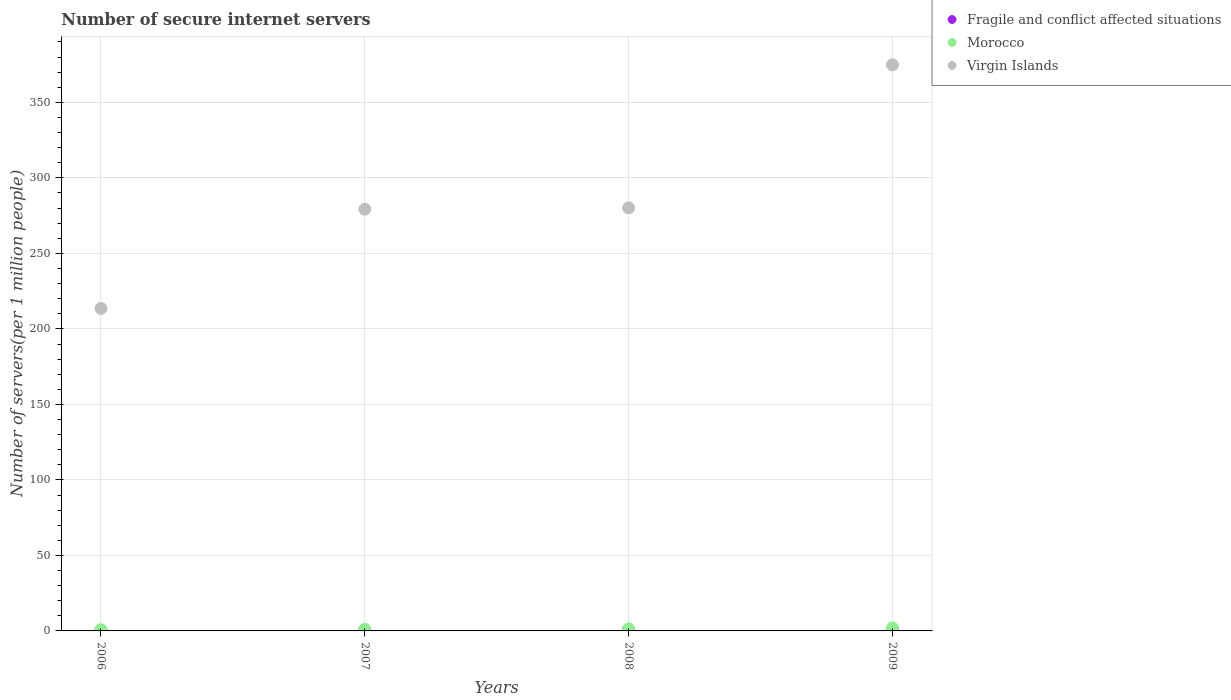How many different coloured dotlines are there?
Provide a short and direct response. 3. What is the number of secure internet servers in Virgin Islands in 2006?
Make the answer very short. 213.56. Across all years, what is the maximum number of secure internet servers in Fragile and conflict affected situations?
Make the answer very short. 0.55. Across all years, what is the minimum number of secure internet servers in Fragile and conflict affected situations?
Give a very brief answer. 0.33. In which year was the number of secure internet servers in Fragile and conflict affected situations maximum?
Make the answer very short. 2009. What is the total number of secure internet servers in Fragile and conflict affected situations in the graph?
Give a very brief answer. 1.84. What is the difference between the number of secure internet servers in Fragile and conflict affected situations in 2007 and that in 2009?
Give a very brief answer. -0.16. What is the difference between the number of secure internet servers in Virgin Islands in 2008 and the number of secure internet servers in Fragile and conflict affected situations in 2007?
Ensure brevity in your answer.  279.74. What is the average number of secure internet servers in Fragile and conflict affected situations per year?
Ensure brevity in your answer.  0.46. In the year 2009, what is the difference between the number of secure internet servers in Virgin Islands and number of secure internet servers in Morocco?
Give a very brief answer. 372.9. What is the ratio of the number of secure internet servers in Virgin Islands in 2006 to that in 2008?
Ensure brevity in your answer.  0.76. Is the number of secure internet servers in Fragile and conflict affected situations in 2007 less than that in 2008?
Offer a terse response. Yes. What is the difference between the highest and the second highest number of secure internet servers in Virgin Islands?
Your answer should be compact. 94.72. What is the difference between the highest and the lowest number of secure internet servers in Virgin Islands?
Provide a succinct answer. 161.3. What is the difference between two consecutive major ticks on the Y-axis?
Keep it short and to the point. 50. Does the graph contain any zero values?
Your response must be concise. No. Does the graph contain grids?
Offer a very short reply. Yes. How many legend labels are there?
Ensure brevity in your answer.  3. What is the title of the graph?
Ensure brevity in your answer.  Number of secure internet servers. Does "Marshall Islands" appear as one of the legend labels in the graph?
Provide a short and direct response. No. What is the label or title of the X-axis?
Your response must be concise. Years. What is the label or title of the Y-axis?
Offer a terse response. Number of servers(per 1 million people). What is the Number of servers(per 1 million people) of Fragile and conflict affected situations in 2006?
Your response must be concise. 0.33. What is the Number of servers(per 1 million people) of Morocco in 2006?
Your answer should be compact. 0.78. What is the Number of servers(per 1 million people) of Virgin Islands in 2006?
Provide a short and direct response. 213.56. What is the Number of servers(per 1 million people) in Fragile and conflict affected situations in 2007?
Provide a succinct answer. 0.4. What is the Number of servers(per 1 million people) of Morocco in 2007?
Ensure brevity in your answer.  1.06. What is the Number of servers(per 1 million people) of Virgin Islands in 2007?
Offer a very short reply. 279.27. What is the Number of servers(per 1 million people) of Fragile and conflict affected situations in 2008?
Offer a terse response. 0.55. What is the Number of servers(per 1 million people) of Morocco in 2008?
Give a very brief answer. 1.4. What is the Number of servers(per 1 million people) in Virgin Islands in 2008?
Your response must be concise. 280.14. What is the Number of servers(per 1 million people) in Fragile and conflict affected situations in 2009?
Give a very brief answer. 0.55. What is the Number of servers(per 1 million people) of Morocco in 2009?
Keep it short and to the point. 1.95. What is the Number of servers(per 1 million people) in Virgin Islands in 2009?
Ensure brevity in your answer.  374.86. Across all years, what is the maximum Number of servers(per 1 million people) in Fragile and conflict affected situations?
Provide a short and direct response. 0.55. Across all years, what is the maximum Number of servers(per 1 million people) in Morocco?
Provide a short and direct response. 1.95. Across all years, what is the maximum Number of servers(per 1 million people) in Virgin Islands?
Provide a short and direct response. 374.86. Across all years, what is the minimum Number of servers(per 1 million people) of Fragile and conflict affected situations?
Provide a succinct answer. 0.33. Across all years, what is the minimum Number of servers(per 1 million people) of Morocco?
Give a very brief answer. 0.78. Across all years, what is the minimum Number of servers(per 1 million people) in Virgin Islands?
Give a very brief answer. 213.56. What is the total Number of servers(per 1 million people) in Fragile and conflict affected situations in the graph?
Keep it short and to the point. 1.84. What is the total Number of servers(per 1 million people) of Morocco in the graph?
Your response must be concise. 5.2. What is the total Number of servers(per 1 million people) in Virgin Islands in the graph?
Give a very brief answer. 1147.82. What is the difference between the Number of servers(per 1 million people) of Fragile and conflict affected situations in 2006 and that in 2007?
Offer a very short reply. -0.07. What is the difference between the Number of servers(per 1 million people) of Morocco in 2006 and that in 2007?
Your answer should be very brief. -0.28. What is the difference between the Number of servers(per 1 million people) in Virgin Islands in 2006 and that in 2007?
Give a very brief answer. -65.71. What is the difference between the Number of servers(per 1 million people) in Fragile and conflict affected situations in 2006 and that in 2008?
Offer a very short reply. -0.22. What is the difference between the Number of servers(per 1 million people) in Morocco in 2006 and that in 2008?
Offer a very short reply. -0.62. What is the difference between the Number of servers(per 1 million people) of Virgin Islands in 2006 and that in 2008?
Give a very brief answer. -66.58. What is the difference between the Number of servers(per 1 million people) of Fragile and conflict affected situations in 2006 and that in 2009?
Offer a very short reply. -0.22. What is the difference between the Number of servers(per 1 million people) of Morocco in 2006 and that in 2009?
Offer a very short reply. -1.17. What is the difference between the Number of servers(per 1 million people) in Virgin Islands in 2006 and that in 2009?
Your answer should be very brief. -161.3. What is the difference between the Number of servers(per 1 million people) of Fragile and conflict affected situations in 2007 and that in 2008?
Your response must be concise. -0.15. What is the difference between the Number of servers(per 1 million people) in Morocco in 2007 and that in 2008?
Give a very brief answer. -0.34. What is the difference between the Number of servers(per 1 million people) in Virgin Islands in 2007 and that in 2008?
Keep it short and to the point. -0.87. What is the difference between the Number of servers(per 1 million people) of Fragile and conflict affected situations in 2007 and that in 2009?
Provide a succinct answer. -0.16. What is the difference between the Number of servers(per 1 million people) of Morocco in 2007 and that in 2009?
Make the answer very short. -0.89. What is the difference between the Number of servers(per 1 million people) of Virgin Islands in 2007 and that in 2009?
Keep it short and to the point. -95.59. What is the difference between the Number of servers(per 1 million people) in Fragile and conflict affected situations in 2008 and that in 2009?
Offer a very short reply. -0. What is the difference between the Number of servers(per 1 million people) of Morocco in 2008 and that in 2009?
Ensure brevity in your answer.  -0.55. What is the difference between the Number of servers(per 1 million people) in Virgin Islands in 2008 and that in 2009?
Give a very brief answer. -94.72. What is the difference between the Number of servers(per 1 million people) in Fragile and conflict affected situations in 2006 and the Number of servers(per 1 million people) in Morocco in 2007?
Provide a short and direct response. -0.73. What is the difference between the Number of servers(per 1 million people) of Fragile and conflict affected situations in 2006 and the Number of servers(per 1 million people) of Virgin Islands in 2007?
Give a very brief answer. -278.94. What is the difference between the Number of servers(per 1 million people) of Morocco in 2006 and the Number of servers(per 1 million people) of Virgin Islands in 2007?
Offer a terse response. -278.49. What is the difference between the Number of servers(per 1 million people) of Fragile and conflict affected situations in 2006 and the Number of servers(per 1 million people) of Morocco in 2008?
Your answer should be compact. -1.07. What is the difference between the Number of servers(per 1 million people) of Fragile and conflict affected situations in 2006 and the Number of servers(per 1 million people) of Virgin Islands in 2008?
Ensure brevity in your answer.  -279.8. What is the difference between the Number of servers(per 1 million people) in Morocco in 2006 and the Number of servers(per 1 million people) in Virgin Islands in 2008?
Offer a terse response. -279.35. What is the difference between the Number of servers(per 1 million people) of Fragile and conflict affected situations in 2006 and the Number of servers(per 1 million people) of Morocco in 2009?
Provide a short and direct response. -1.62. What is the difference between the Number of servers(per 1 million people) of Fragile and conflict affected situations in 2006 and the Number of servers(per 1 million people) of Virgin Islands in 2009?
Your answer should be very brief. -374.52. What is the difference between the Number of servers(per 1 million people) of Morocco in 2006 and the Number of servers(per 1 million people) of Virgin Islands in 2009?
Give a very brief answer. -374.08. What is the difference between the Number of servers(per 1 million people) in Fragile and conflict affected situations in 2007 and the Number of servers(per 1 million people) in Morocco in 2008?
Make the answer very short. -1. What is the difference between the Number of servers(per 1 million people) of Fragile and conflict affected situations in 2007 and the Number of servers(per 1 million people) of Virgin Islands in 2008?
Your response must be concise. -279.74. What is the difference between the Number of servers(per 1 million people) of Morocco in 2007 and the Number of servers(per 1 million people) of Virgin Islands in 2008?
Keep it short and to the point. -279.07. What is the difference between the Number of servers(per 1 million people) of Fragile and conflict affected situations in 2007 and the Number of servers(per 1 million people) of Morocco in 2009?
Offer a terse response. -1.56. What is the difference between the Number of servers(per 1 million people) of Fragile and conflict affected situations in 2007 and the Number of servers(per 1 million people) of Virgin Islands in 2009?
Your answer should be compact. -374.46. What is the difference between the Number of servers(per 1 million people) of Morocco in 2007 and the Number of servers(per 1 million people) of Virgin Islands in 2009?
Your answer should be compact. -373.79. What is the difference between the Number of servers(per 1 million people) of Fragile and conflict affected situations in 2008 and the Number of servers(per 1 million people) of Morocco in 2009?
Your answer should be compact. -1.4. What is the difference between the Number of servers(per 1 million people) in Fragile and conflict affected situations in 2008 and the Number of servers(per 1 million people) in Virgin Islands in 2009?
Offer a very short reply. -374.31. What is the difference between the Number of servers(per 1 million people) in Morocco in 2008 and the Number of servers(per 1 million people) in Virgin Islands in 2009?
Your answer should be very brief. -373.45. What is the average Number of servers(per 1 million people) in Fragile and conflict affected situations per year?
Your answer should be compact. 0.46. What is the average Number of servers(per 1 million people) in Morocco per year?
Make the answer very short. 1.3. What is the average Number of servers(per 1 million people) in Virgin Islands per year?
Provide a short and direct response. 286.95. In the year 2006, what is the difference between the Number of servers(per 1 million people) in Fragile and conflict affected situations and Number of servers(per 1 million people) in Morocco?
Your answer should be compact. -0.45. In the year 2006, what is the difference between the Number of servers(per 1 million people) of Fragile and conflict affected situations and Number of servers(per 1 million people) of Virgin Islands?
Offer a very short reply. -213.22. In the year 2006, what is the difference between the Number of servers(per 1 million people) in Morocco and Number of servers(per 1 million people) in Virgin Islands?
Give a very brief answer. -212.77. In the year 2007, what is the difference between the Number of servers(per 1 million people) in Fragile and conflict affected situations and Number of servers(per 1 million people) in Morocco?
Make the answer very short. -0.66. In the year 2007, what is the difference between the Number of servers(per 1 million people) of Fragile and conflict affected situations and Number of servers(per 1 million people) of Virgin Islands?
Keep it short and to the point. -278.87. In the year 2007, what is the difference between the Number of servers(per 1 million people) in Morocco and Number of servers(per 1 million people) in Virgin Islands?
Ensure brevity in your answer.  -278.21. In the year 2008, what is the difference between the Number of servers(per 1 million people) of Fragile and conflict affected situations and Number of servers(per 1 million people) of Morocco?
Your answer should be compact. -0.85. In the year 2008, what is the difference between the Number of servers(per 1 million people) in Fragile and conflict affected situations and Number of servers(per 1 million people) in Virgin Islands?
Offer a terse response. -279.59. In the year 2008, what is the difference between the Number of servers(per 1 million people) in Morocco and Number of servers(per 1 million people) in Virgin Islands?
Your answer should be compact. -278.73. In the year 2009, what is the difference between the Number of servers(per 1 million people) of Fragile and conflict affected situations and Number of servers(per 1 million people) of Morocco?
Ensure brevity in your answer.  -1.4. In the year 2009, what is the difference between the Number of servers(per 1 million people) of Fragile and conflict affected situations and Number of servers(per 1 million people) of Virgin Islands?
Make the answer very short. -374.3. In the year 2009, what is the difference between the Number of servers(per 1 million people) in Morocco and Number of servers(per 1 million people) in Virgin Islands?
Make the answer very short. -372.9. What is the ratio of the Number of servers(per 1 million people) in Fragile and conflict affected situations in 2006 to that in 2007?
Offer a terse response. 0.84. What is the ratio of the Number of servers(per 1 million people) of Morocco in 2006 to that in 2007?
Offer a very short reply. 0.73. What is the ratio of the Number of servers(per 1 million people) in Virgin Islands in 2006 to that in 2007?
Your answer should be compact. 0.76. What is the ratio of the Number of servers(per 1 million people) in Fragile and conflict affected situations in 2006 to that in 2008?
Your answer should be very brief. 0.61. What is the ratio of the Number of servers(per 1 million people) of Morocco in 2006 to that in 2008?
Ensure brevity in your answer.  0.56. What is the ratio of the Number of servers(per 1 million people) of Virgin Islands in 2006 to that in 2008?
Give a very brief answer. 0.76. What is the ratio of the Number of servers(per 1 million people) in Fragile and conflict affected situations in 2006 to that in 2009?
Provide a succinct answer. 0.6. What is the ratio of the Number of servers(per 1 million people) of Morocco in 2006 to that in 2009?
Your answer should be very brief. 0.4. What is the ratio of the Number of servers(per 1 million people) in Virgin Islands in 2006 to that in 2009?
Keep it short and to the point. 0.57. What is the ratio of the Number of servers(per 1 million people) in Fragile and conflict affected situations in 2007 to that in 2008?
Your answer should be very brief. 0.73. What is the ratio of the Number of servers(per 1 million people) in Morocco in 2007 to that in 2008?
Give a very brief answer. 0.76. What is the ratio of the Number of servers(per 1 million people) in Virgin Islands in 2007 to that in 2008?
Offer a very short reply. 1. What is the ratio of the Number of servers(per 1 million people) of Fragile and conflict affected situations in 2007 to that in 2009?
Offer a very short reply. 0.72. What is the ratio of the Number of servers(per 1 million people) of Morocco in 2007 to that in 2009?
Your response must be concise. 0.54. What is the ratio of the Number of servers(per 1 million people) of Virgin Islands in 2007 to that in 2009?
Ensure brevity in your answer.  0.74. What is the ratio of the Number of servers(per 1 million people) in Morocco in 2008 to that in 2009?
Give a very brief answer. 0.72. What is the ratio of the Number of servers(per 1 million people) in Virgin Islands in 2008 to that in 2009?
Your answer should be very brief. 0.75. What is the difference between the highest and the second highest Number of servers(per 1 million people) of Fragile and conflict affected situations?
Provide a short and direct response. 0. What is the difference between the highest and the second highest Number of servers(per 1 million people) in Morocco?
Keep it short and to the point. 0.55. What is the difference between the highest and the second highest Number of servers(per 1 million people) of Virgin Islands?
Provide a short and direct response. 94.72. What is the difference between the highest and the lowest Number of servers(per 1 million people) of Fragile and conflict affected situations?
Your response must be concise. 0.22. What is the difference between the highest and the lowest Number of servers(per 1 million people) in Morocco?
Provide a succinct answer. 1.17. What is the difference between the highest and the lowest Number of servers(per 1 million people) of Virgin Islands?
Offer a very short reply. 161.3. 